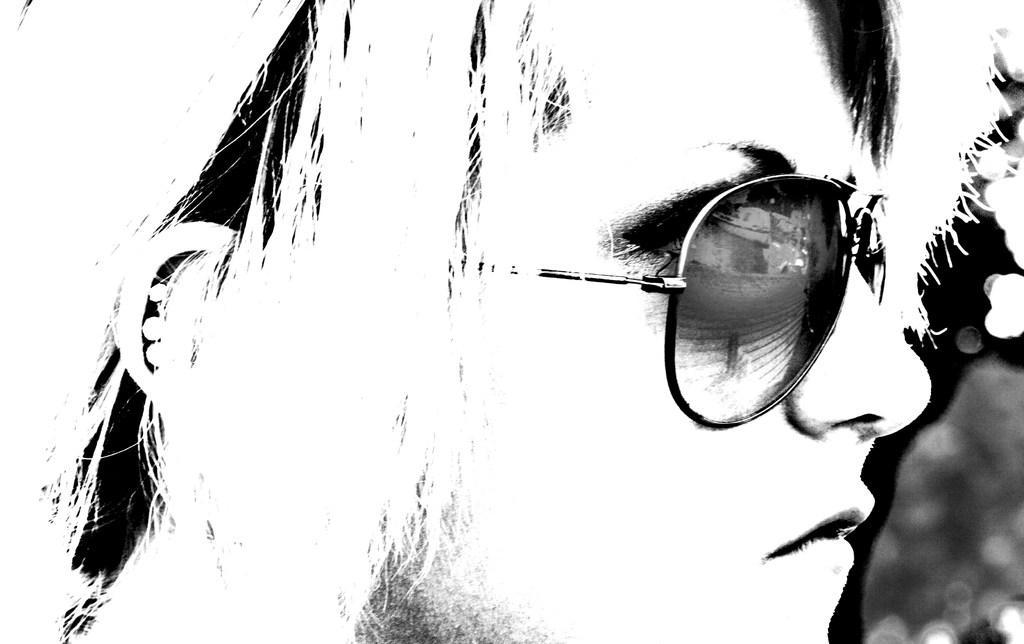Please provide a concise description of this image. In this picture there is a girl in the image. 